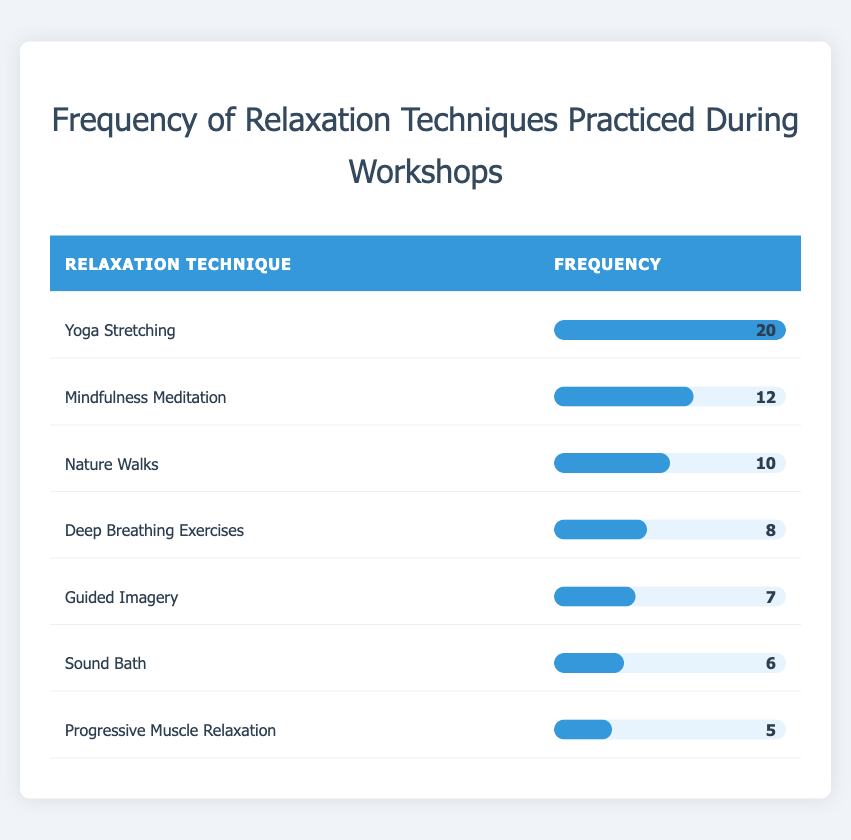What is the most practiced relaxation technique? By looking at the frequencies in the table, "Yoga Stretching" has the highest frequency at 20, making it the most practiced relaxation technique.
Answer: Yoga Stretching How many times was "Mindfulness Meditation" practiced? The frequency for "Mindfulness Meditation" is directly provided in the table as 12.
Answer: 12 Which relaxation technique was practiced the least? The technique with the lowest frequency in the table is "Progressive Muscle Relaxation," which has a frequency of 5.
Answer: Progressive Muscle Relaxation What is the total frequency of relaxation techniques practiced during the workshops? To find the total frequency, we sum up all the frequencies: 20 + 12 + 10 + 8 + 7 + 6 + 5 = 68.
Answer: 68 Is "Guided Imagery" practiced more than "Deep Breathing Exercises"? In the table, "Guided Imagery" has a frequency of 7, while "Deep Breathing Exercises" has a frequency of 8. Therefore, "Guided Imagery" is practiced less than "Deep Breathing Exercises."
Answer: No What is the average frequency of relaxation techniques? To calculate the average, we divide the total frequency (68) by the number of techniques (7): 68 / 7 = approximately 9.71.
Answer: 9.71 Are "Nature Walks" and "Sound Bath" practiced equally often? In the table, "Nature Walks" has a frequency of 10, while "Sound Bath" has a frequency of 6. Therefore, they are not practiced equally often.
Answer: No Which techniques have a frequency greater than 7? By examining the table, the techniques with frequencies greater than 7 are "Yoga Stretching" (20), "Mindfulness Meditation" (12), "Nature Walks" (10), and "Deep Breathing Exercises" (8).
Answer: Yoga Stretching, Mindfulness Meditation, Nature Walks, Deep Breathing Exercises What is the difference in frequency between the most and least practiced techniques? The most practiced technique, "Yoga Stretching," has a frequency of 20, and the least practiced technique, "Progressive Muscle Relaxation," has a frequency of 5. The difference is calculated as 20 - 5 = 15.
Answer: 15 